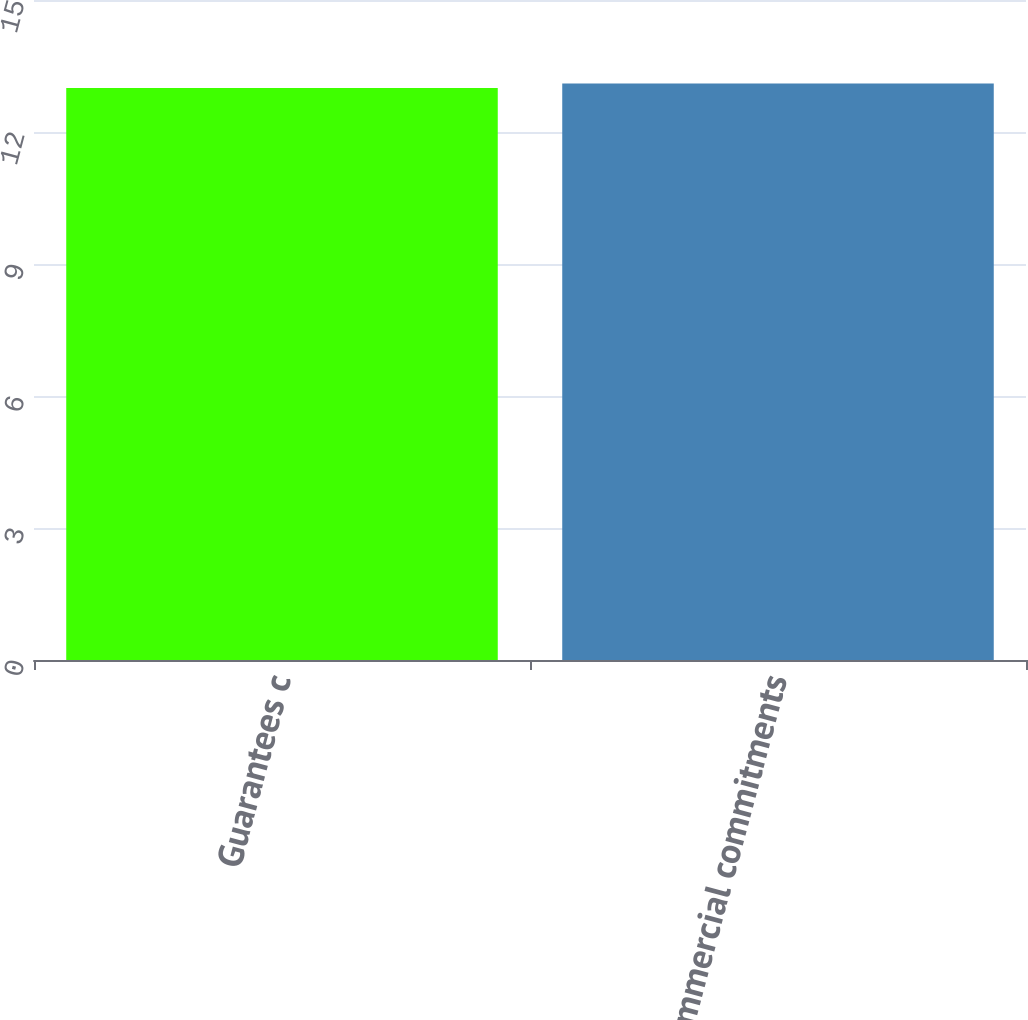Convert chart. <chart><loc_0><loc_0><loc_500><loc_500><bar_chart><fcel>Guarantees c<fcel>Total commercial commitments<nl><fcel>13<fcel>13.1<nl></chart> 